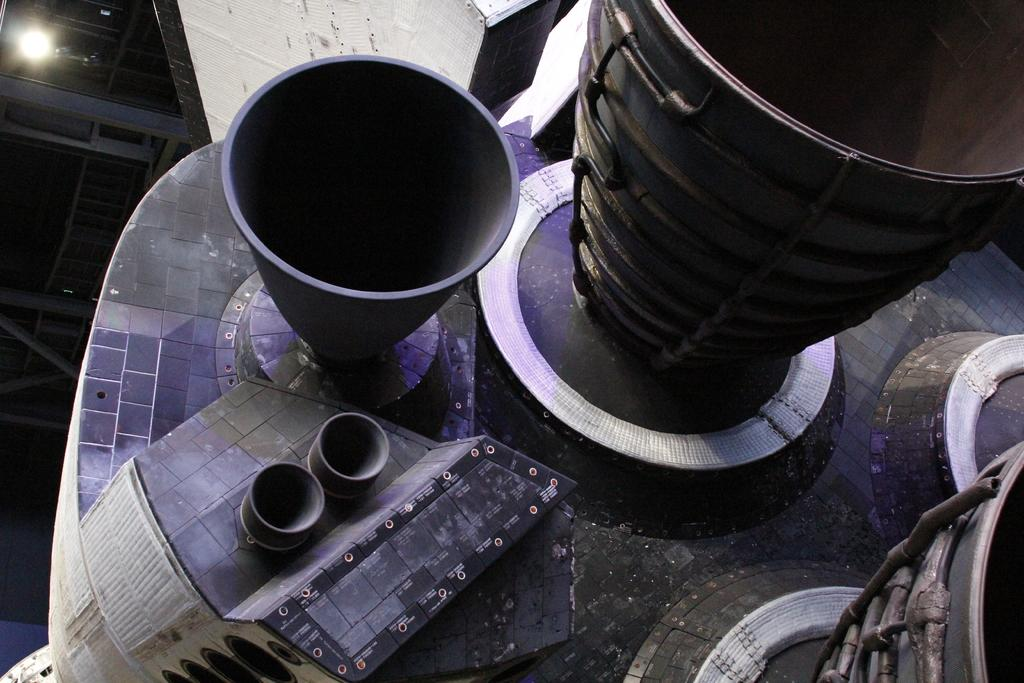What type of furniture is present in the image? There is a desk in the image. What objects are on the desk? There are instruments on the desk. Can you describe the lighting in the image? There is a light beside the desk. What type of shirt is the brain wearing in the image? There is no brain or shirt present in the image; it features a desk with instruments and a light beside it. 